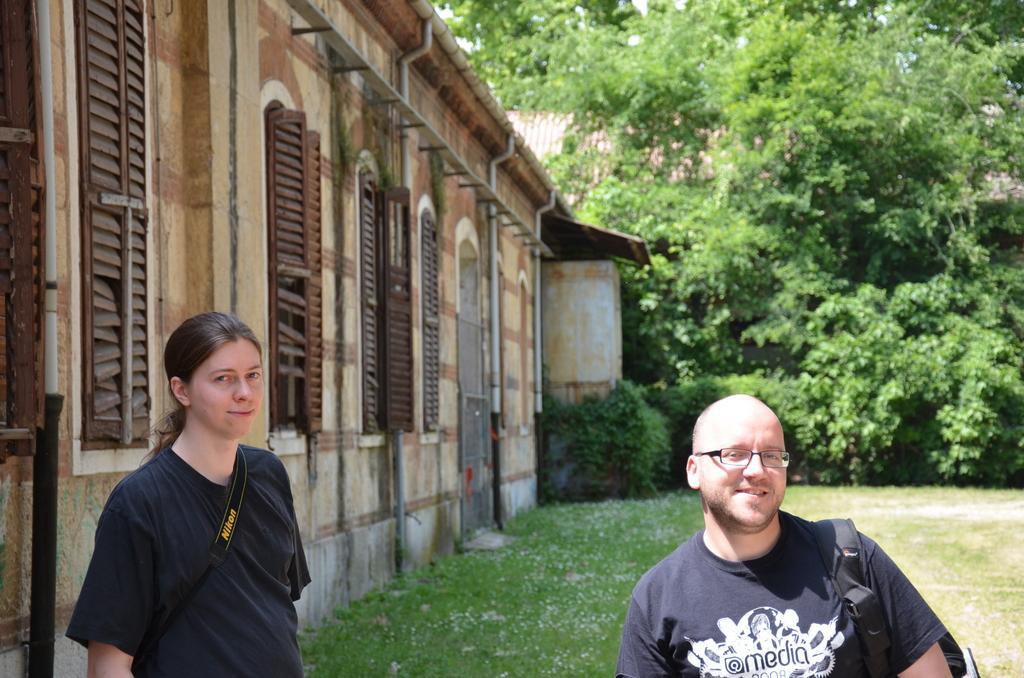Please provide a concise description of this image. On the right there is a person in black t-shirt and wearing a backpack. On the left there is a woman in black t-shirt. Towards left there is a building. In the background towards right there are trees and plants. In the center of the picture it is grass. 